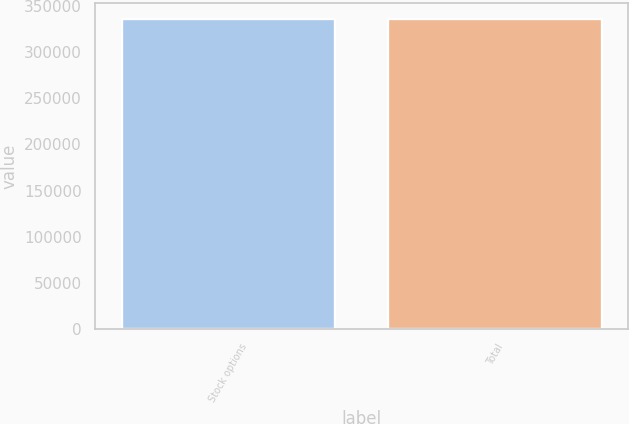Convert chart to OTSL. <chart><loc_0><loc_0><loc_500><loc_500><bar_chart><fcel>Stock options<fcel>Total<nl><fcel>336133<fcel>336133<nl></chart> 